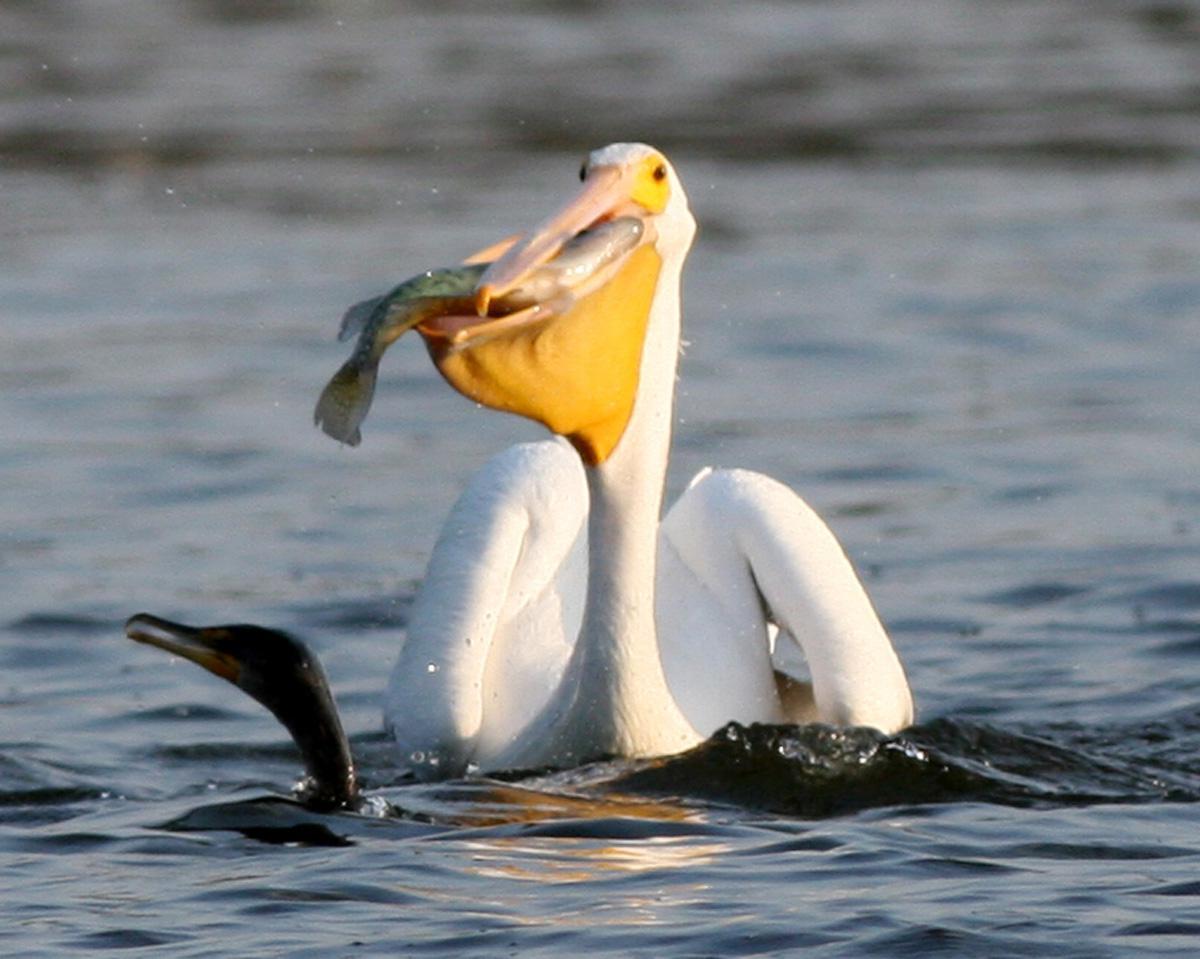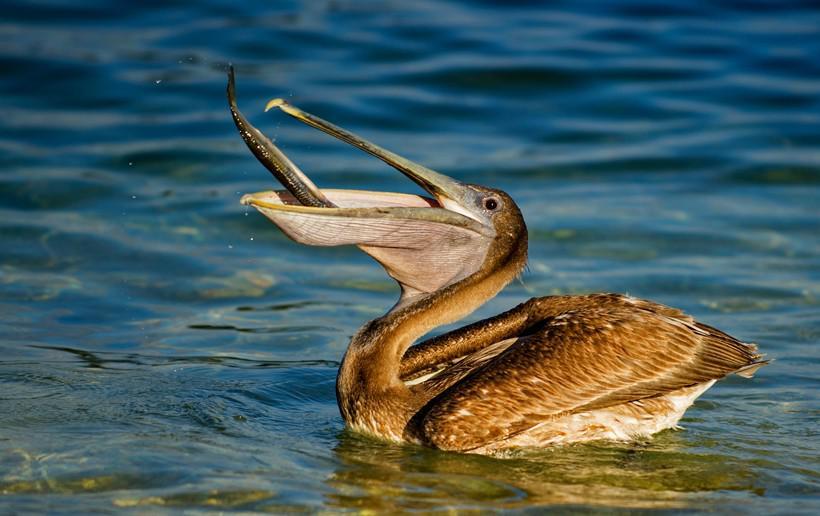The first image is the image on the left, the second image is the image on the right. Analyze the images presented: Is the assertion "An image shows a left-facing dark pelican that has a fish in its bill." valid? Answer yes or no. Yes. The first image is the image on the left, the second image is the image on the right. Assess this claim about the two images: "The bird is facing the left as it eats its food.". Correct or not? Answer yes or no. Yes. 